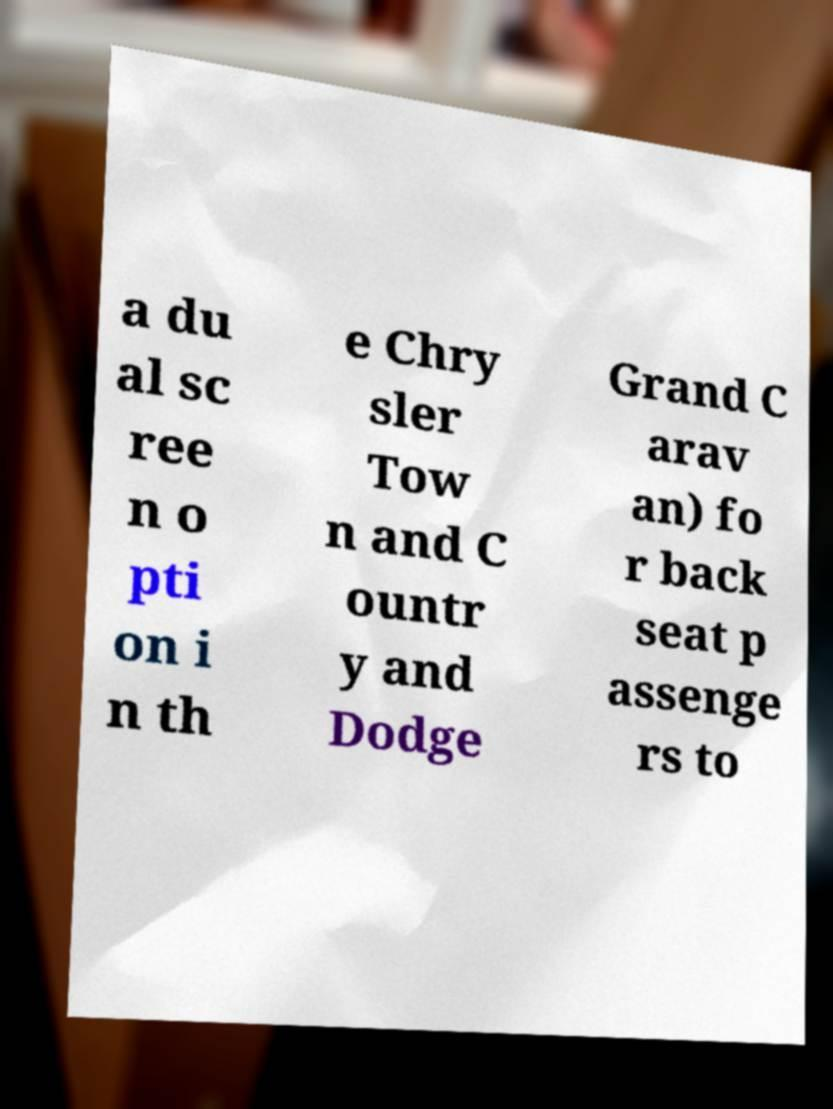Could you assist in decoding the text presented in this image and type it out clearly? a du al sc ree n o pti on i n th e Chry sler Tow n and C ountr y and Dodge Grand C arav an) fo r back seat p assenge rs to 